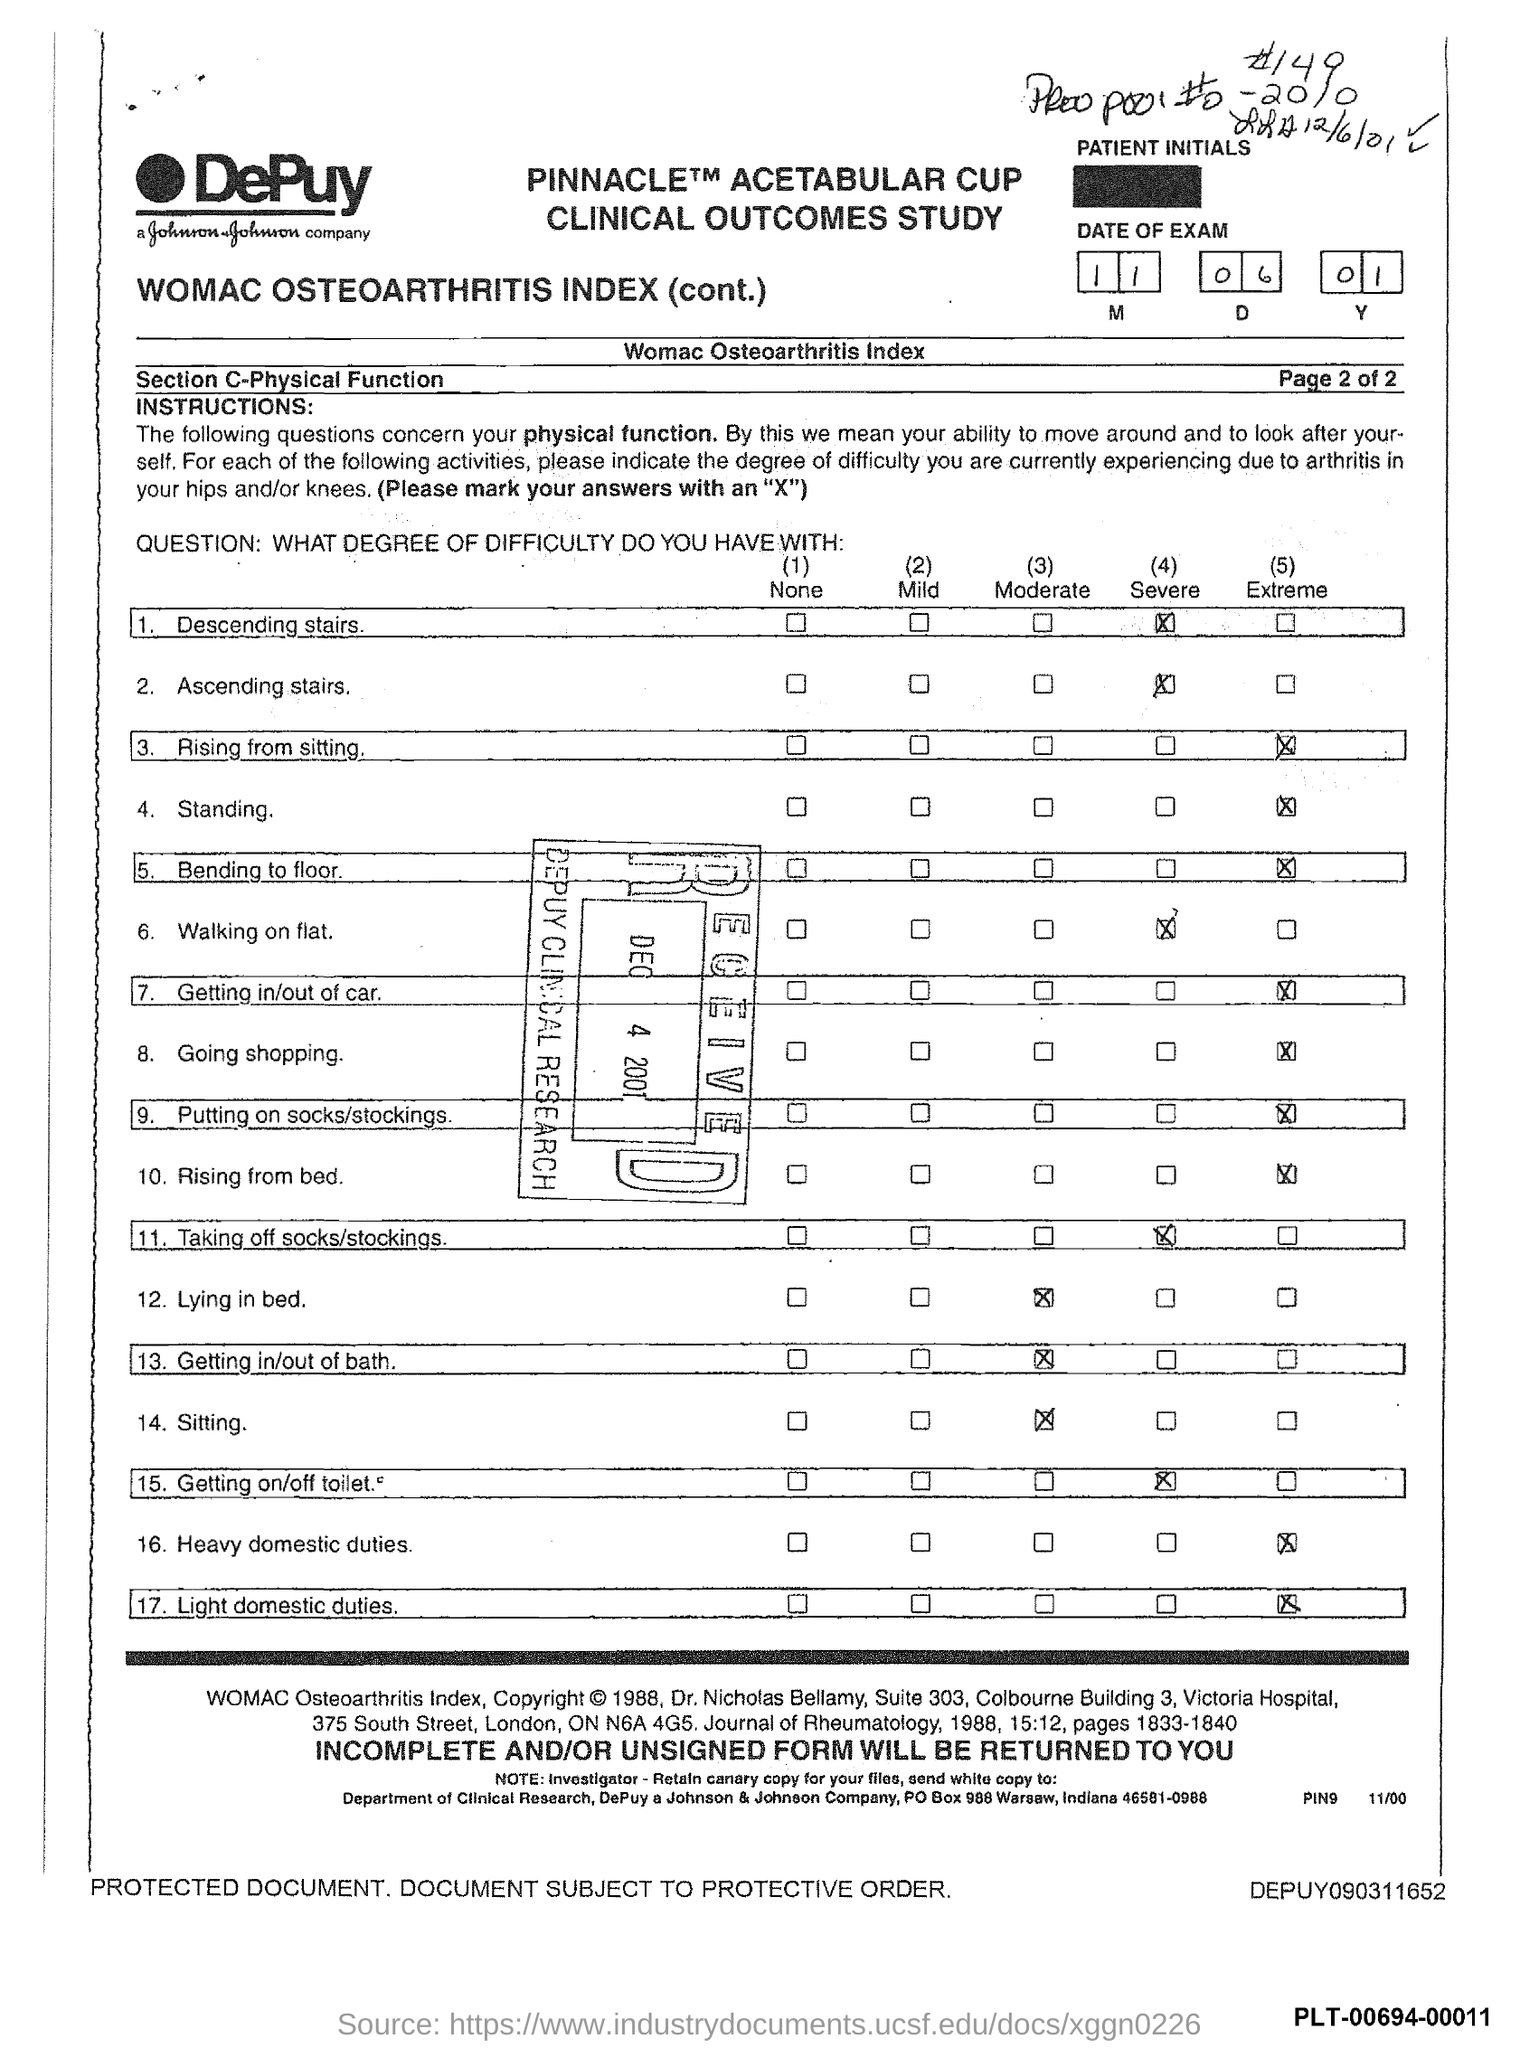Outline some significant characteristics in this image. Johnson & Johnson Company is located in the state of Indiana. The postal box number for Johnson & Johnson Company is 988. This information is not commonly known and would likely require a specific inquiry or research to obtain. 